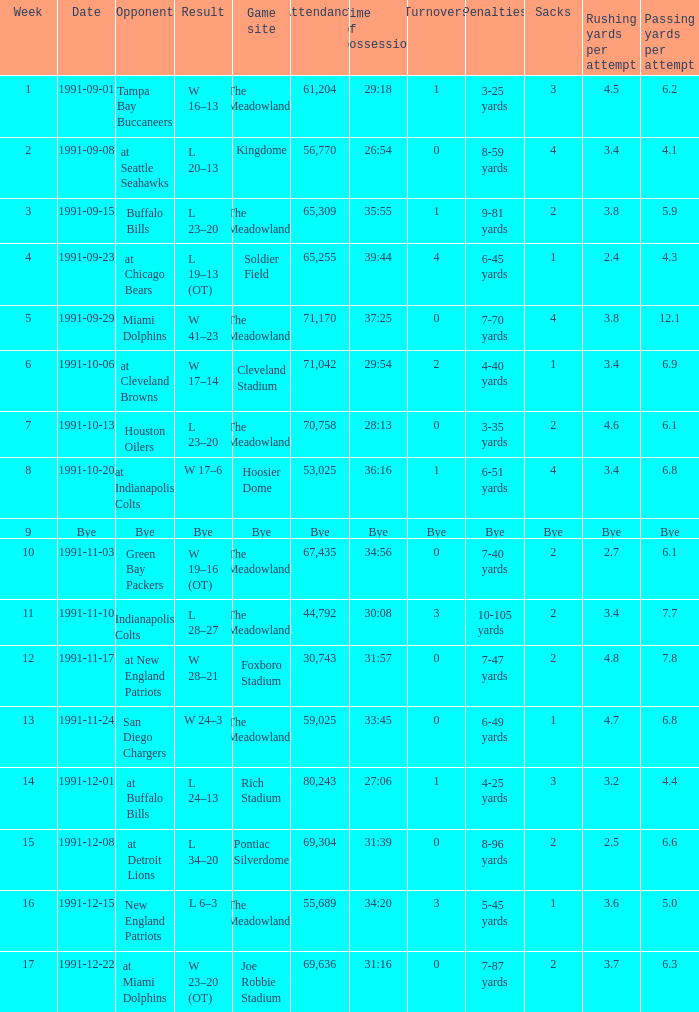What was the Result of the Game at the Meadowlands on 1991-09-01? W 16–13. 